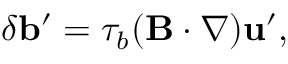Convert formula to latex. <formula><loc_0><loc_0><loc_500><loc_500>\delta { b } ^ { \prime } = \tau _ { b } ( { B } \cdot \nabla ) { u } ^ { \prime } ,</formula> 